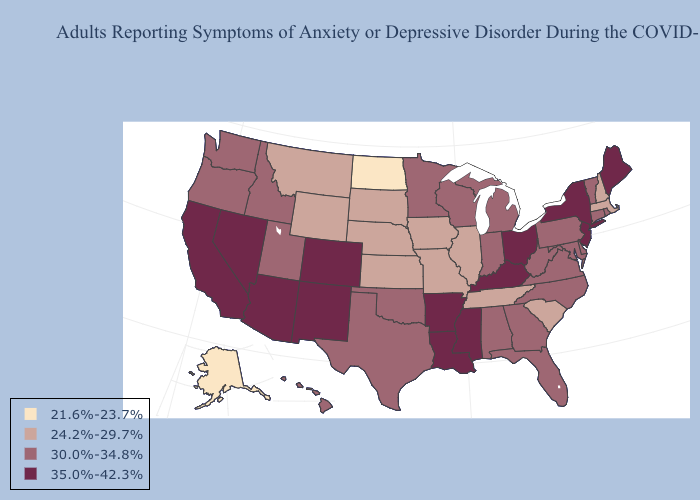Does the first symbol in the legend represent the smallest category?
Be succinct. Yes. Name the states that have a value in the range 35.0%-42.3%?
Answer briefly. Arizona, Arkansas, California, Colorado, Kentucky, Louisiana, Maine, Mississippi, Nevada, New Jersey, New Mexico, New York, Ohio. Name the states that have a value in the range 21.6%-23.7%?
Short answer required. Alaska, North Dakota. What is the lowest value in the Northeast?
Write a very short answer. 24.2%-29.7%. What is the value of South Dakota?
Write a very short answer. 24.2%-29.7%. What is the highest value in states that border Pennsylvania?
Concise answer only. 35.0%-42.3%. What is the value of Tennessee?
Short answer required. 24.2%-29.7%. Among the states that border Maine , which have the highest value?
Give a very brief answer. New Hampshire. What is the value of Minnesota?
Keep it brief. 30.0%-34.8%. What is the value of Rhode Island?
Be succinct. 30.0%-34.8%. Name the states that have a value in the range 35.0%-42.3%?
Keep it brief. Arizona, Arkansas, California, Colorado, Kentucky, Louisiana, Maine, Mississippi, Nevada, New Jersey, New Mexico, New York, Ohio. Among the states that border South Dakota , does Iowa have the highest value?
Be succinct. No. Does the first symbol in the legend represent the smallest category?
Keep it brief. Yes. What is the value of Tennessee?
Answer briefly. 24.2%-29.7%. Which states have the lowest value in the Northeast?
Short answer required. Massachusetts, New Hampshire. 